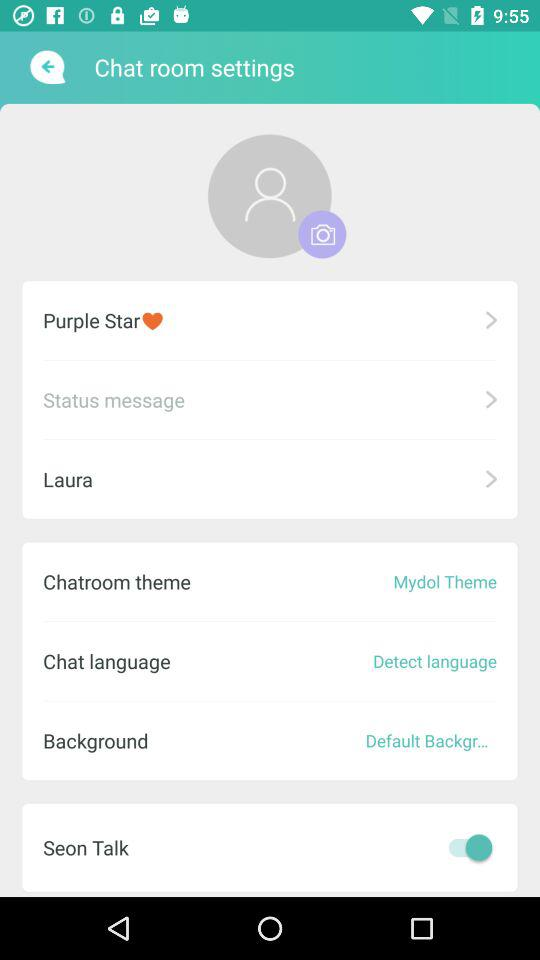What is the user name? The user name is Laura. 